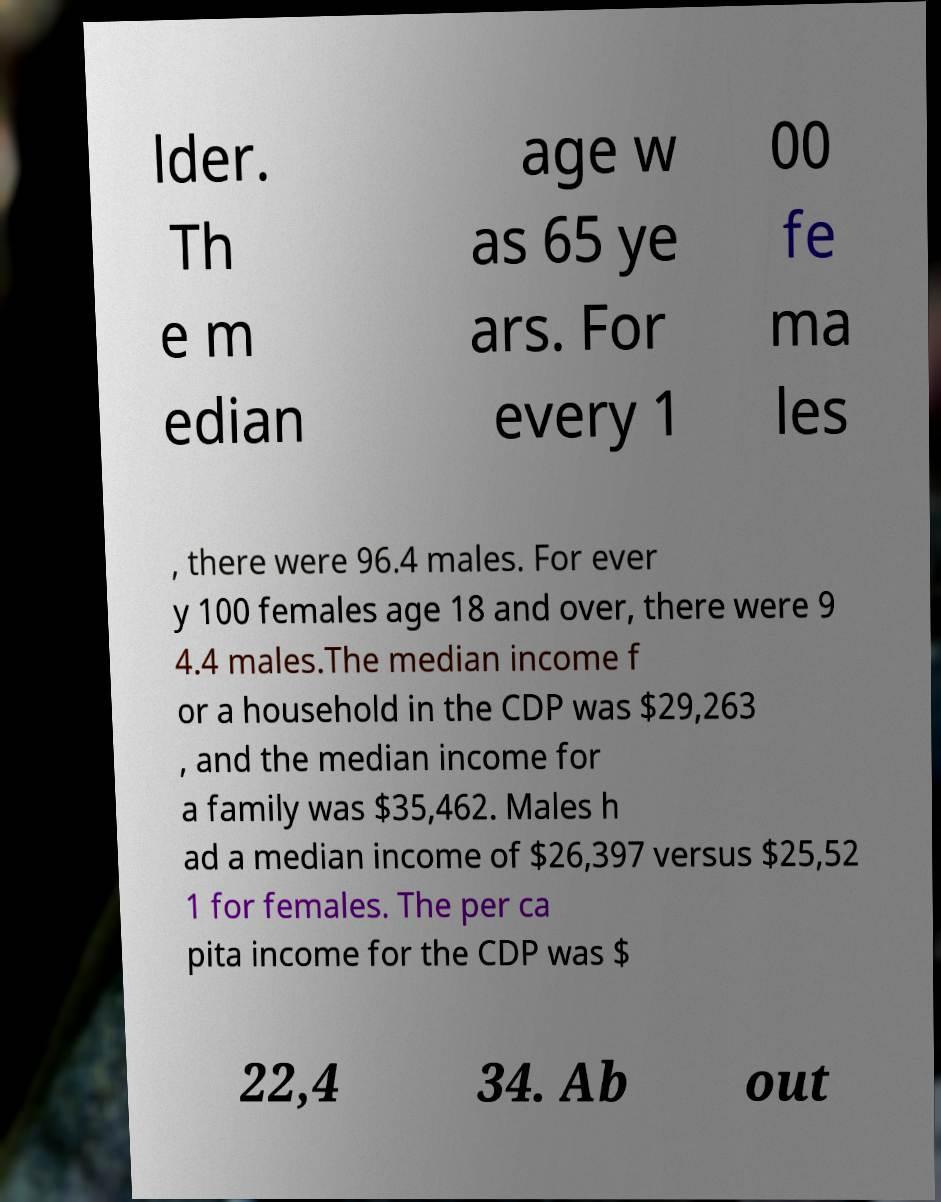Can you accurately transcribe the text from the provided image for me? lder. Th e m edian age w as 65 ye ars. For every 1 00 fe ma les , there were 96.4 males. For ever y 100 females age 18 and over, there were 9 4.4 males.The median income f or a household in the CDP was $29,263 , and the median income for a family was $35,462. Males h ad a median income of $26,397 versus $25,52 1 for females. The per ca pita income for the CDP was $ 22,4 34. Ab out 